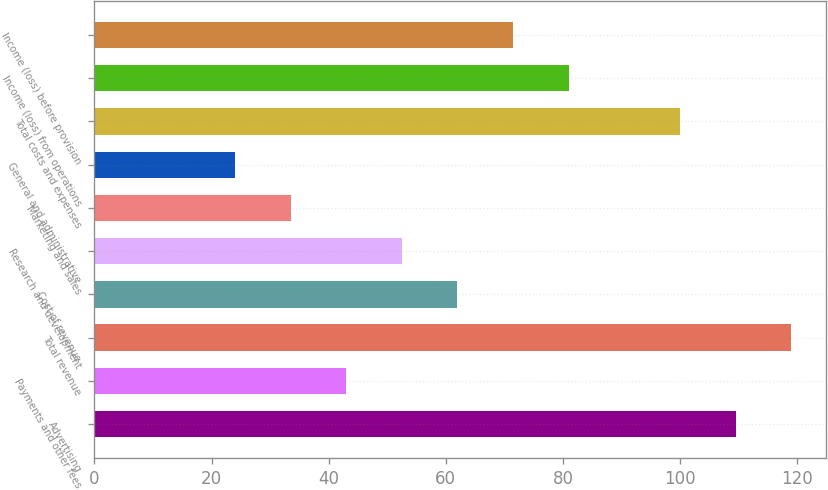<chart> <loc_0><loc_0><loc_500><loc_500><bar_chart><fcel>Advertising<fcel>Payments and other fees<fcel>Total revenue<fcel>Cost of revenue<fcel>Research and development<fcel>Marketing and sales<fcel>General and administrative<fcel>Total costs and expenses<fcel>Income (loss) from operations<fcel>Income (loss) before provision<nl><fcel>109.5<fcel>43<fcel>119<fcel>62<fcel>52.5<fcel>33.5<fcel>24<fcel>100<fcel>81<fcel>71.5<nl></chart> 